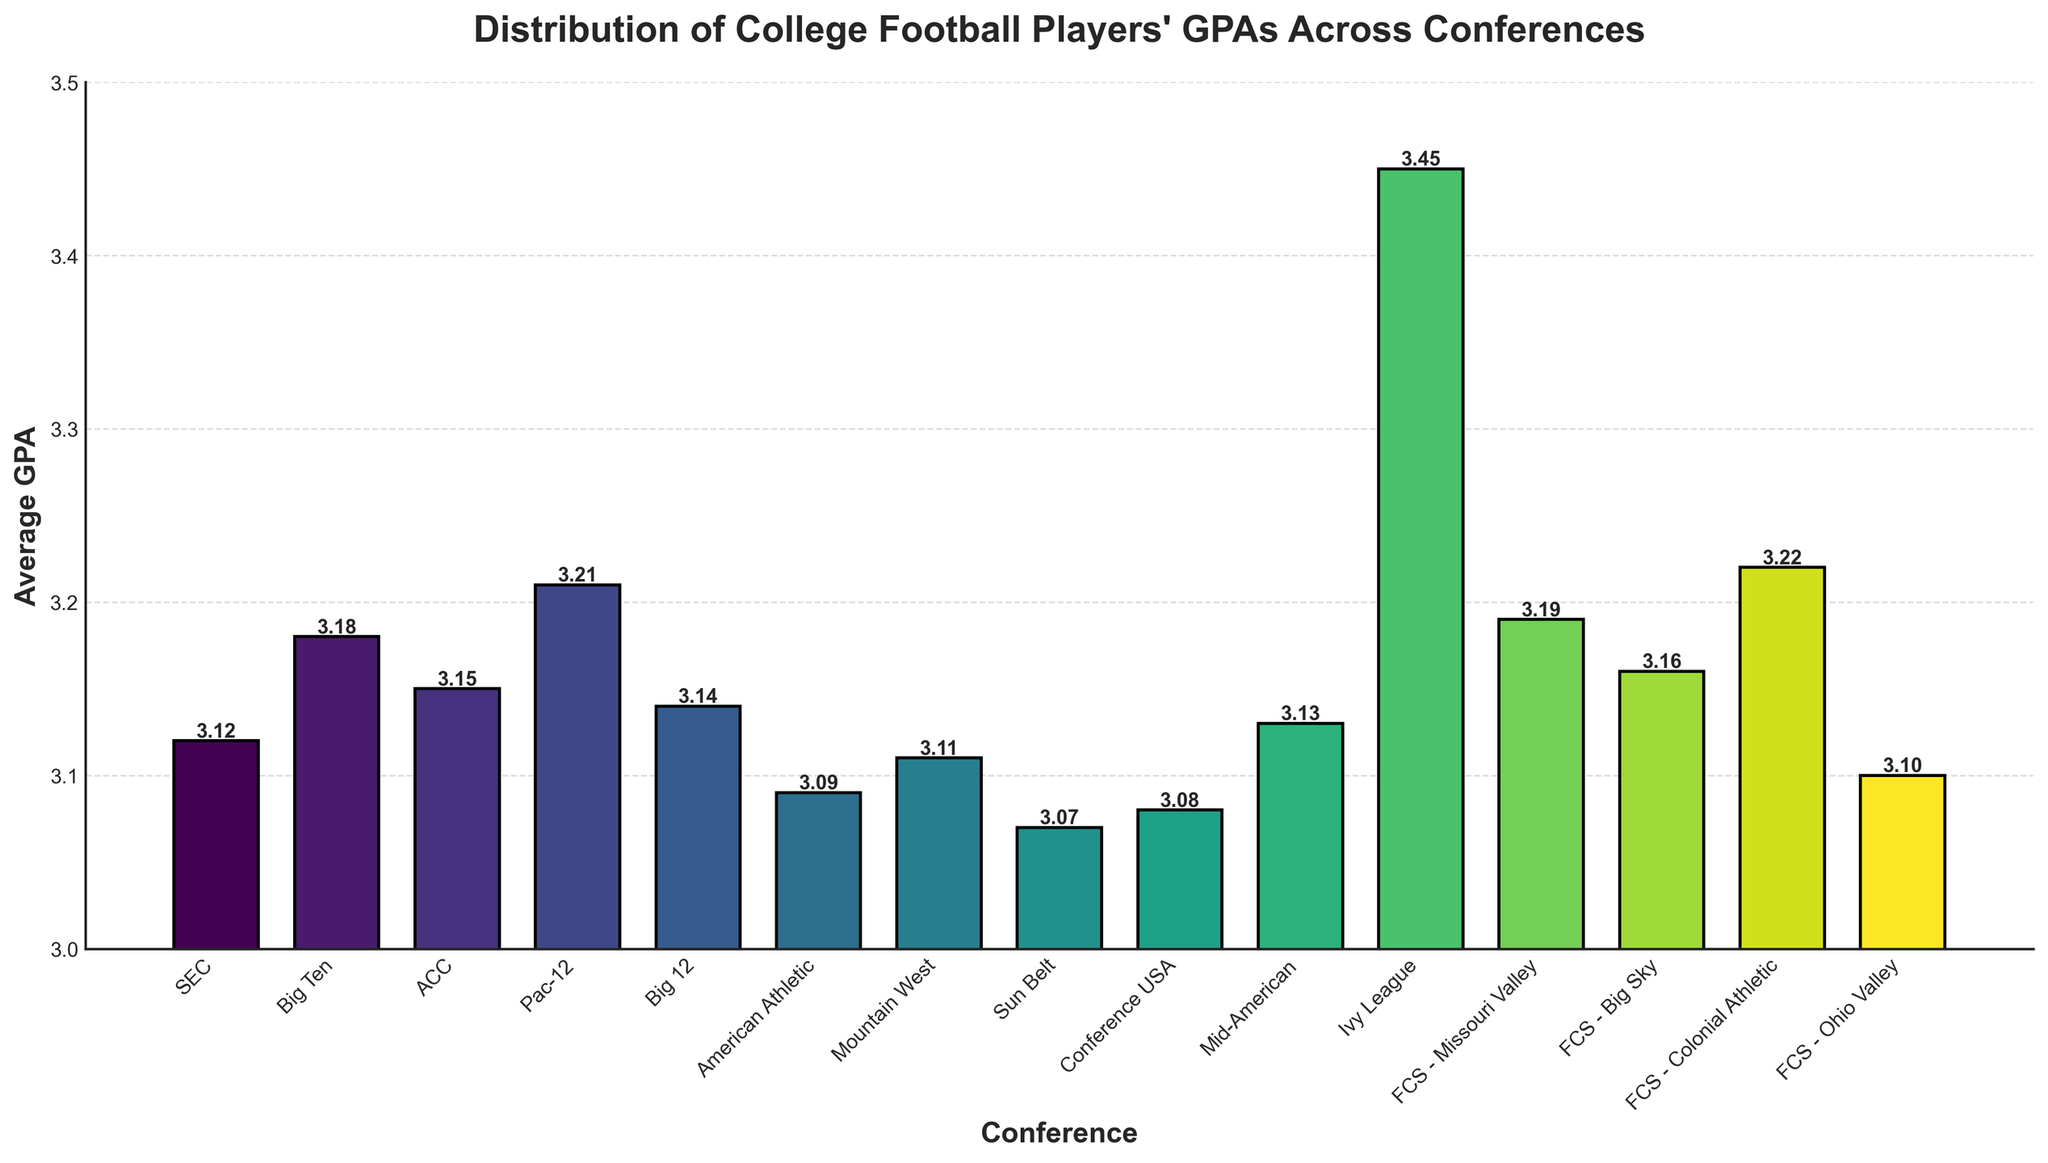Which conference has the highest average GPA? The bar corresponding to the Ivy League conference has the highest height, indicating it has the highest GPA.
Answer: Ivy League What is the average GPA for the Big Ten conference? Find the height of the bar labeled "Big Ten" on the x-axis, and it shows the value as 3.18.
Answer: 3.18 How does the average GPA of the Pac-12 compare to the Big 12? Compare the heights of the bars labeled "Pac-12" and "Big 12". The Pac-12 has a GPA of 3.21, and the Big 12 has 3.14.
Answer: Pac-12 is higher What is the difference in average GPA between the Ivy League and Mid-American conferences? Subtract the height of the Mid-American bar (3.13) from the height of the Ivy League bar (3.45).
Answer: 0.32 What is the average GPA of the bottom three performing conferences? Identify the bars with the lowest heights: Sun Belt (3.07), Conference USA (3.08), and American Athletic (3.09). Then average these values: (3.07 + 3.08 + 3.09) / 3.
Answer: 3.08 Are there any conferences with an average GPA exactly equal to 3.15? Check the bars corresponding to each conference for the value of 3.15 and identify the ACC bar.
Answer: ACC Which conference has a lower average GPA: SEC or Mountain West? Compare the heights of the bars labeled "SEC" and "Mountain West". SEC has a GPA of 3.12, and Mountain West has 3.11.
Answer: Mountain West is lower What is the range of GPAs observed across all conferences? Find the difference between the maximum GPA (Ivy League, 3.45) and the minimum GPA (Sun Belt, 3.07).
Answer: 0.38 Which FCS conference has the highest average GPA? Compare the FCS conferences and identify the bar with the highest height. The Colonial Athletic conference has the highest GPA of 3.22.
Answer: Colonial Athletic If we were to visualize the bars representing the SEC and Big Ten conferences side by side, how much taller is the Big Ten bar compared to the SEC bar? Subtract the height of the SEC bar (3.12) from the height of the Big Ten bar (3.18).
Answer: 0.06 